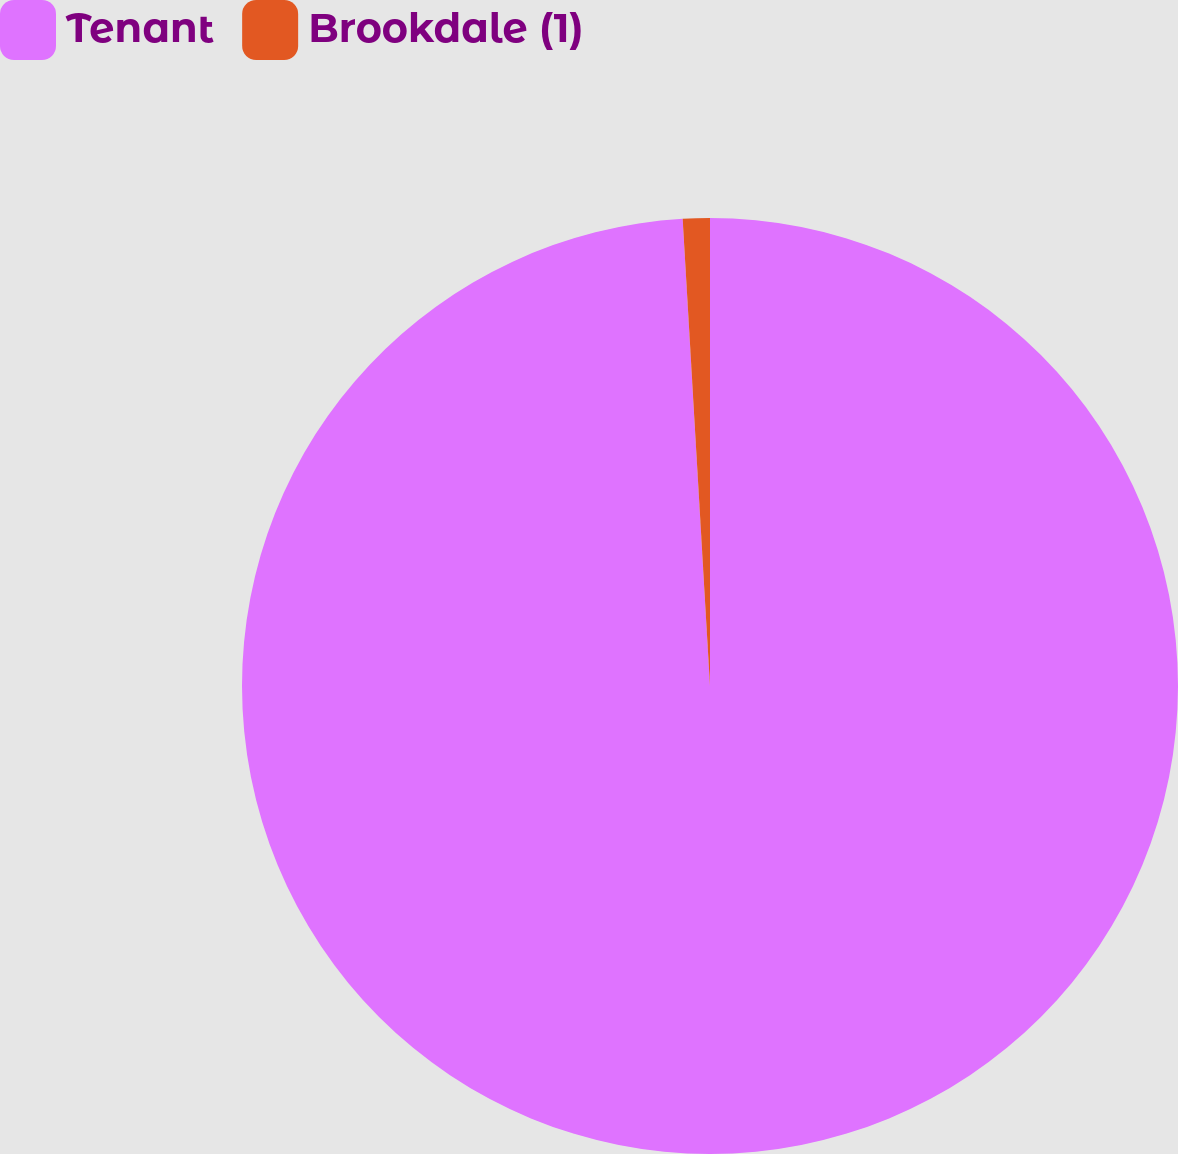Convert chart. <chart><loc_0><loc_0><loc_500><loc_500><pie_chart><fcel>Tenant<fcel>Brookdale (1)<nl><fcel>99.07%<fcel>0.93%<nl></chart> 